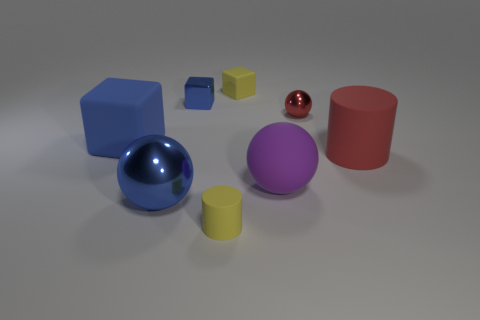There is a red matte cylinder behind the purple sphere; is its size the same as the yellow cylinder?
Your answer should be compact. No. What number of other objects are there of the same shape as the large shiny thing?
Your response must be concise. 2. Is the number of tiny yellow matte cylinders greater than the number of red objects?
Your response must be concise. No. There is a sphere that is left of the cube that is to the right of the matte cylinder left of the red sphere; what is its size?
Offer a terse response. Large. What size is the matte block that is left of the small yellow block?
Provide a succinct answer. Large. How many objects are either small gray metallic balls or tiny cubes that are behind the tiny shiny block?
Provide a succinct answer. 1. What number of other things are the same size as the yellow rubber block?
Offer a very short reply. 3. What is the material of the small red thing that is the same shape as the big blue metallic thing?
Ensure brevity in your answer.  Metal. Is the number of blue spheres that are in front of the purple matte ball greater than the number of tiny gray blocks?
Make the answer very short. Yes. Is there anything else that is the same color as the rubber sphere?
Your response must be concise. No. 